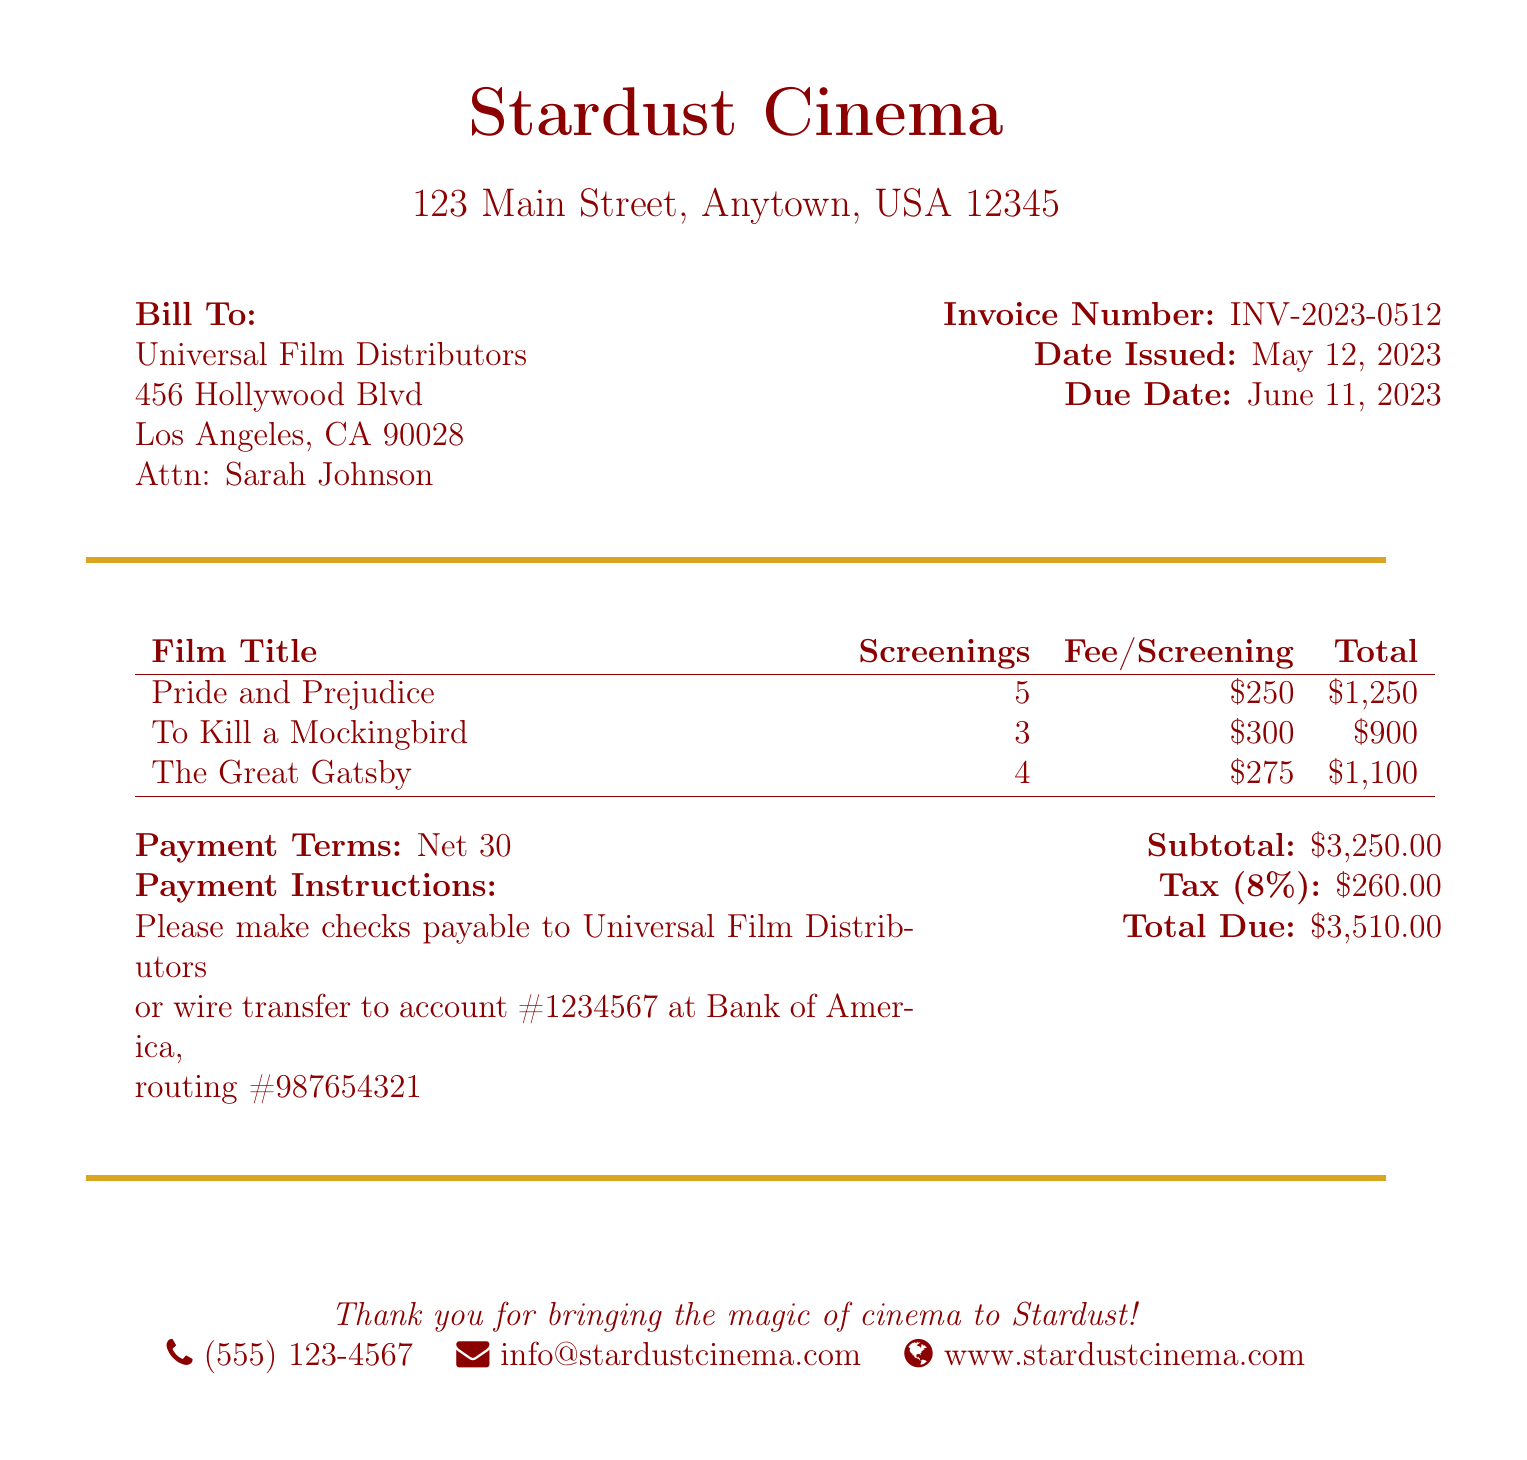what is the total due amount? The total due amount is listed at the bottom of the bill, which includes the subtotal and tax.
Answer: $3,510.00 who is the bill addressed to? The bill is addressed to Universal Film Distributors, which is specified at the top of the document.
Answer: Universal Film Distributors how many screenings of "To Kill a Mockingbird" are planned? The number of screenings is provided in the table under the "Screenings" column for that particular film.
Answer: 3 what is the fee per screening for "The Great Gatsby"? The fee per screening is mentioned in the table alongside the film title in the "Fee/Screening" column.
Answer: $275 when is the due date for this invoice? The due date is clearly listed alongside the invoice number in the upper right corner of the document.
Answer: June 11, 2023 what percentage is the tax applied to the subtotal? The tax percentage is noted in the payment details section, indicating how much tax is added to the subtotal.
Answer: 8% how much is the subtotal before tax? The subtotal amount is presented right above the tax calculation in the billing details.
Answer: $3,250.00 who should checks be made payable to? The payment instructions specify who the checks should be made payable to.
Answer: Universal Film Distributors 